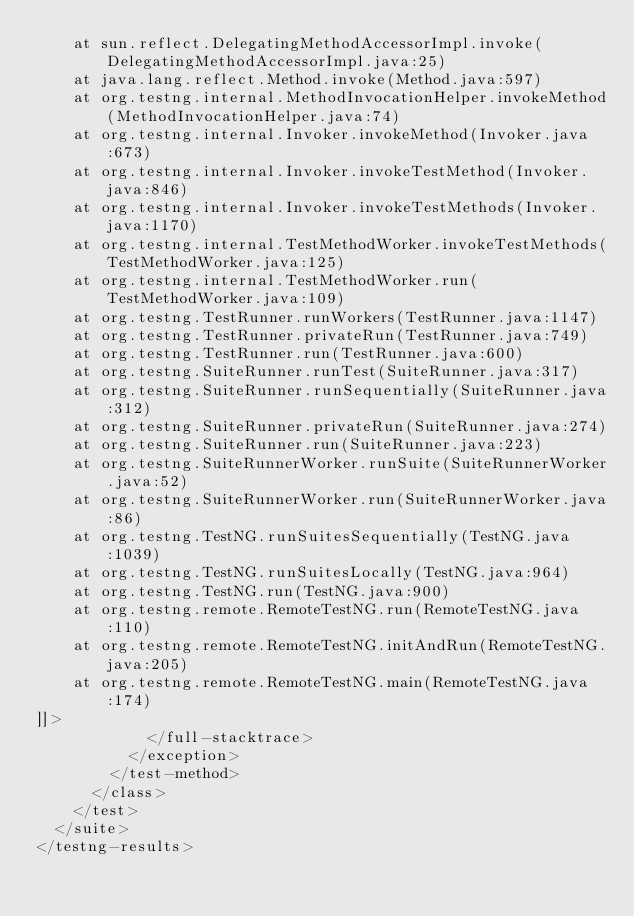<code> <loc_0><loc_0><loc_500><loc_500><_XML_>	at sun.reflect.DelegatingMethodAccessorImpl.invoke(DelegatingMethodAccessorImpl.java:25)
	at java.lang.reflect.Method.invoke(Method.java:597)
	at org.testng.internal.MethodInvocationHelper.invokeMethod(MethodInvocationHelper.java:74)
	at org.testng.internal.Invoker.invokeMethod(Invoker.java:673)
	at org.testng.internal.Invoker.invokeTestMethod(Invoker.java:846)
	at org.testng.internal.Invoker.invokeTestMethods(Invoker.java:1170)
	at org.testng.internal.TestMethodWorker.invokeTestMethods(TestMethodWorker.java:125)
	at org.testng.internal.TestMethodWorker.run(TestMethodWorker.java:109)
	at org.testng.TestRunner.runWorkers(TestRunner.java:1147)
	at org.testng.TestRunner.privateRun(TestRunner.java:749)
	at org.testng.TestRunner.run(TestRunner.java:600)
	at org.testng.SuiteRunner.runTest(SuiteRunner.java:317)
	at org.testng.SuiteRunner.runSequentially(SuiteRunner.java:312)
	at org.testng.SuiteRunner.privateRun(SuiteRunner.java:274)
	at org.testng.SuiteRunner.run(SuiteRunner.java:223)
	at org.testng.SuiteRunnerWorker.runSuite(SuiteRunnerWorker.java:52)
	at org.testng.SuiteRunnerWorker.run(SuiteRunnerWorker.java:86)
	at org.testng.TestNG.runSuitesSequentially(TestNG.java:1039)
	at org.testng.TestNG.runSuitesLocally(TestNG.java:964)
	at org.testng.TestNG.run(TestNG.java:900)
	at org.testng.remote.RemoteTestNG.run(RemoteTestNG.java:110)
	at org.testng.remote.RemoteTestNG.initAndRun(RemoteTestNG.java:205)
	at org.testng.remote.RemoteTestNG.main(RemoteTestNG.java:174)
]]>
            </full-stacktrace>
          </exception>
        </test-method>
      </class>
    </test>
  </suite>
</testng-results>
</code> 